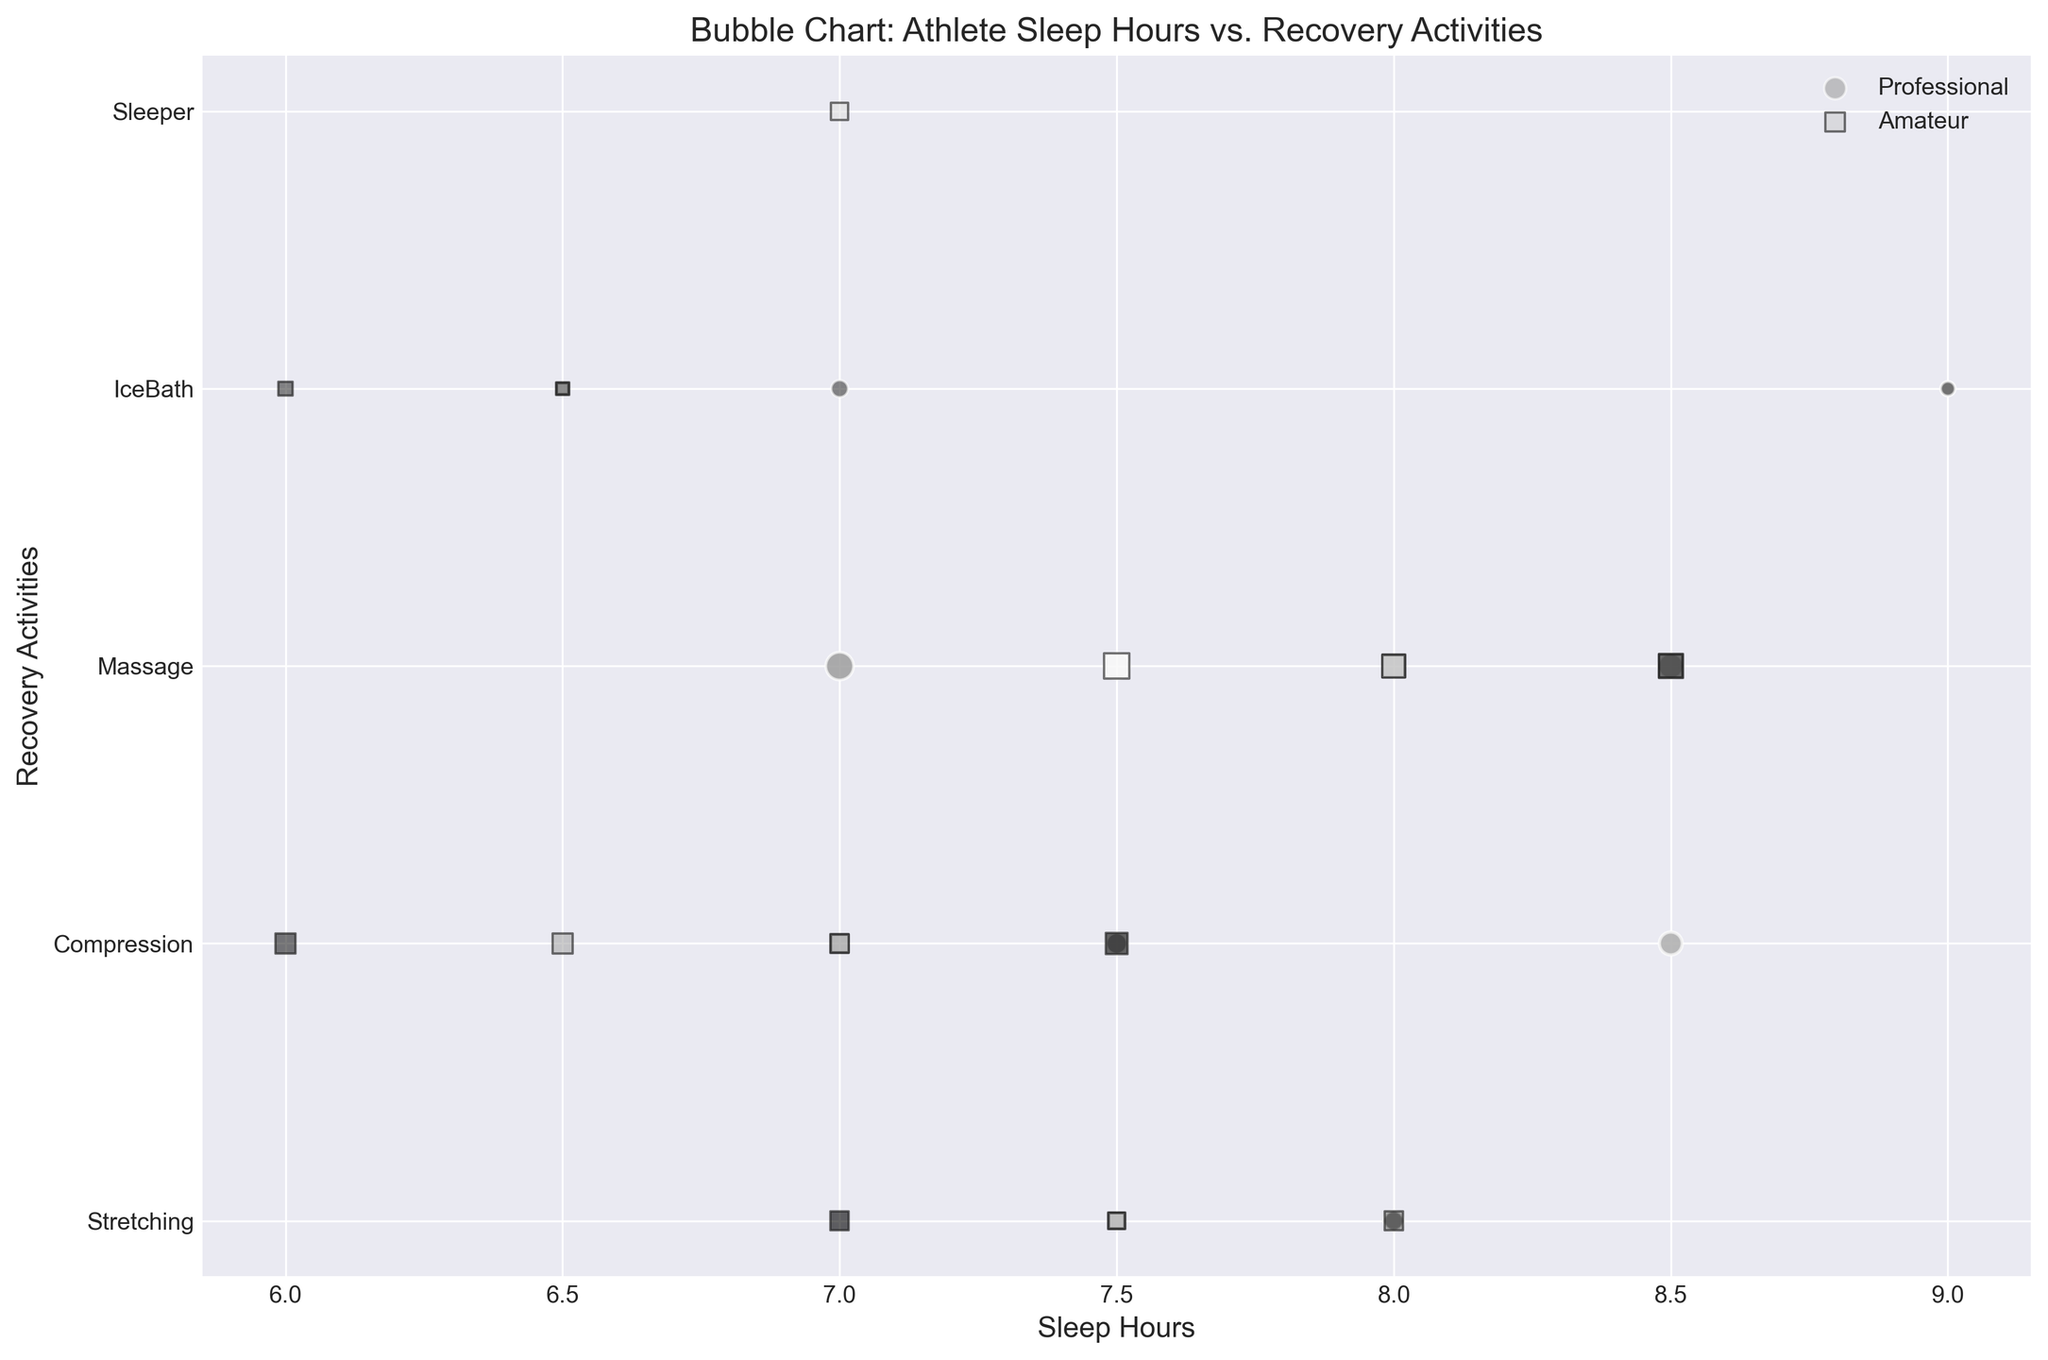What is the difference in average recovery time between professional and amateur athletes? To find the average recovery time for both groups, sum their recovery times and divide by the number of entries. For professionals: (30+45+60+20+25+50+70+15+35+40+55+25+28+42+65+18+34+38)=695. There are 18 entries, so 695/18 = 38.61. For amateurs: (20+30+45+10+25+35+50+15+30+40+55+12+30+28+47+17+22+36+44+26)=587. There are 20 entries, so 587/20 = 29.35. The difference is 38.61 - 29.35 = 9.26
Answer: 9.26 Which group, professional or amateur athletes, has more uniform distribution of sleep hours? From the plot, the sleep hours for professionals mostly range from 7 to 9, and for amateurs, they range from 6 to 8.5. A quick visual check shows the professional athletes have a more concentrated sleep range.
Answer: Professional What's the most common recovery activity among professional athletes? By counting the frequency of recovery activities for professionals in the plot, "Stretching" appears most frequently.
Answer: Stretching Which group is more likely to use ice baths, professionals or amateurs? By examining the sizes and occurrences of bubbles labeled "IceBath" in both professional and amateur groups, professionals have more and larger bubbles.
Answer: Professional What's the total recovery time spent on massage by amateur athletes? Summing the recovery times for "Massage" among amateurs in the figure: 45 + 50 + 55 + 47 + 44 = 241
Answer: 241 Are there any professional athletes who sleep less than 7 hours? Checking the sleep hours for professional athletes, it starts from 7 hours and above, so there are no professionals sleeping less than 7 hours.
Answer: No Do professional athletes spend more time on stretching or compression on average? For professionals, summing up "Stretching" and "Compression" recovery times and dividing by frequency: Stretching - (30+25+35+28+34) = 152/5 = 30.4; Compression - (45+50+40+42+38) = 215/5 = 43.
Answer: Compression What is the total recovery time spent by professionals and amateurs combined? Sum all recovery times for both groups: 695 (professional) + 587 (amateur) = 1282
Answer: 1282 Which activity has the largest average recovery time for amateurs? Calculate average for each activity among amateurs: Stretching (20+25+30+22) = 97/4 = 24.25, Compression (30+35+40+36) = 141/4 = 35.25, Massage (45+50+55+47+44) = 241/5 = 48.2, IceBath (10+15+12+17) = 54/4 = 13.5. Massage has the highest average.
Answer: Massage Is there any overlap in sleep hours for the two groups? Checking the ranges: professionals (7-9) and amateurs (6-8.5). Overlap occurs between 7 and 8.5 hours.
Answer: Yes 